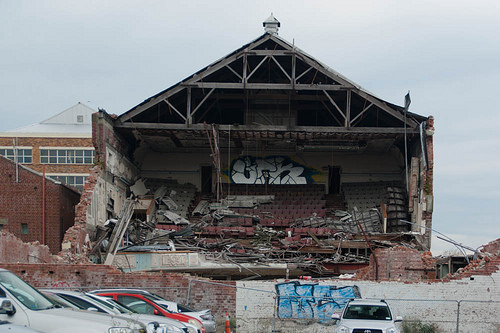<image>
Is the graffiti on the wall? Yes. Looking at the image, I can see the graffiti is positioned on top of the wall, with the wall providing support. Is there a red car next to the white car? No. The red car is not positioned next to the white car. They are located in different areas of the scene. 